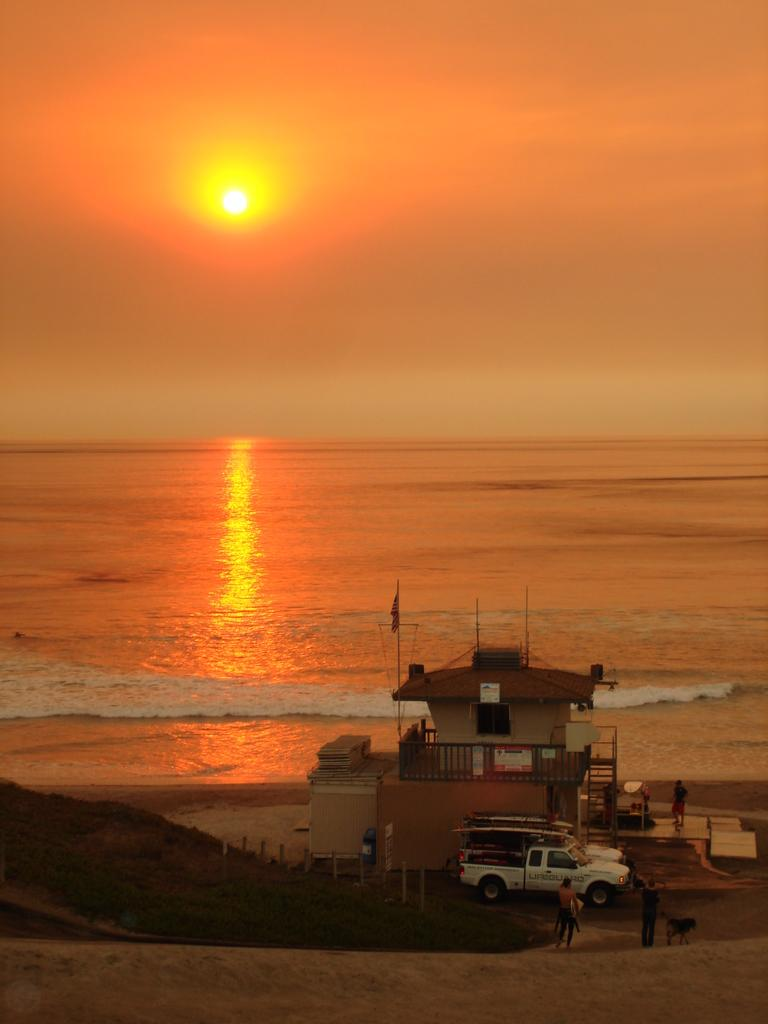What are the people in the image doing? The people in the image are on a path. What else can be seen in the image besides the people? There is a vehicle and a house behind the vehicle in the image. What is visible behind the house? The sea is visible behind the house. What is the condition of the sky in the image? The sun is visible in the sky. What type of nut is being used to create a paste in the image? There is no nut or paste present in the image. Can you tell me how many pigs are visible in the image? There are no pigs present in the image. 